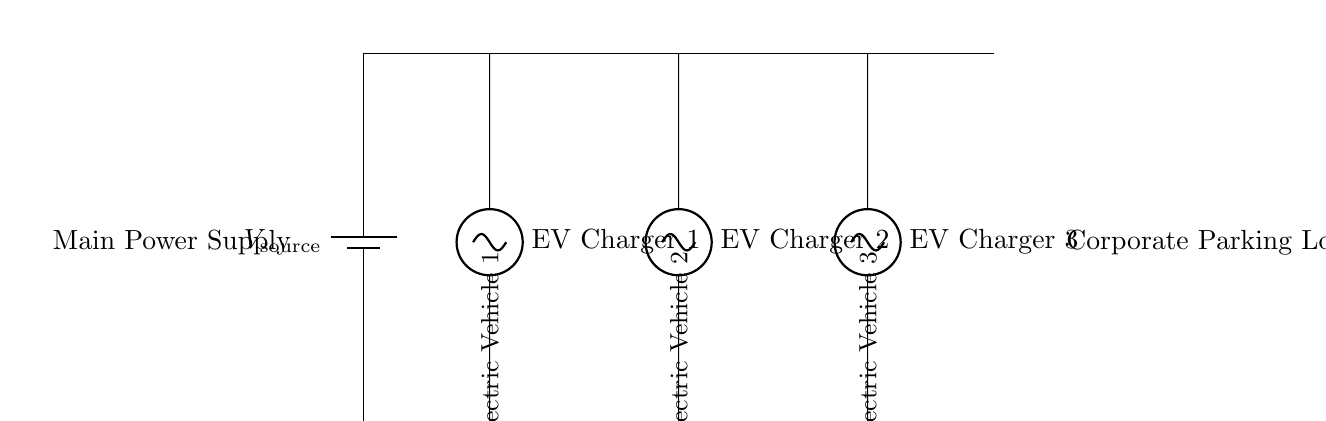What is the source voltage for this circuit? The source voltage is represented as V_source, which indicates the voltage supplied to the circuit but does not specify a numeric value. Based on common setups, this voltage is generally expected to be sufficient for charging electric vehicles but needs to be confirmed from data elsewhere.
Answer: V_source How many electric vehicle chargers are in the setup? The diagram clearly indicates three distinct EV chargers, each labeled as EV Charger 1, EV Charger 2, and EV Charger 3. These chargers are connected in parallel, allowing them to operate simultaneously.
Answer: Three What type of configuration is used in this circuit for the chargers? The circuit depicts a parallel configuration, as indicated by the way the chargers are connected side by side, sharing the same voltage source and allowing individual current paths. This ensures that each charger can operate independently without affecting the others.
Answer: Parallel Which electric vehicle is connected to EV Charger 2? The label near EV Charger 2 indicates it is connected to Electric Vehicle 2, specifically identified in the diagram, which includes annotation for clarity.
Answer: Electric Vehicle 2 What does the label "Main Power Supply" indicate in this circuit? The label "Main Power Supply" denotes the source of energy that powers the entire array of EV chargers in the parking lot, indicating that this is where the circuit receives energy to function.
Answer: Energy source If one EV charger fails, how does that affect the other chargers? Since this is a parallel configuration, a failure in one EV charger would not impact the operation of the other chargers. Each charger operates independently, ensuring continuous charging for the remaining vehicles.
Answer: No effect What does the "Corporate Parking Lot" signify in the context of this circuit? The label "Corporate Parking Lot" suggests the setting where this charging system is installed, indicating its practical application in charging electric vehicles belonging to employees or visitors in a corporate environment.
Answer: Charging location 